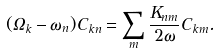<formula> <loc_0><loc_0><loc_500><loc_500>( \Omega _ { k } - \omega _ { n } ) C _ { k n } = \sum _ { m } \frac { K _ { n m } } { 2 \omega } C _ { k m } .</formula> 